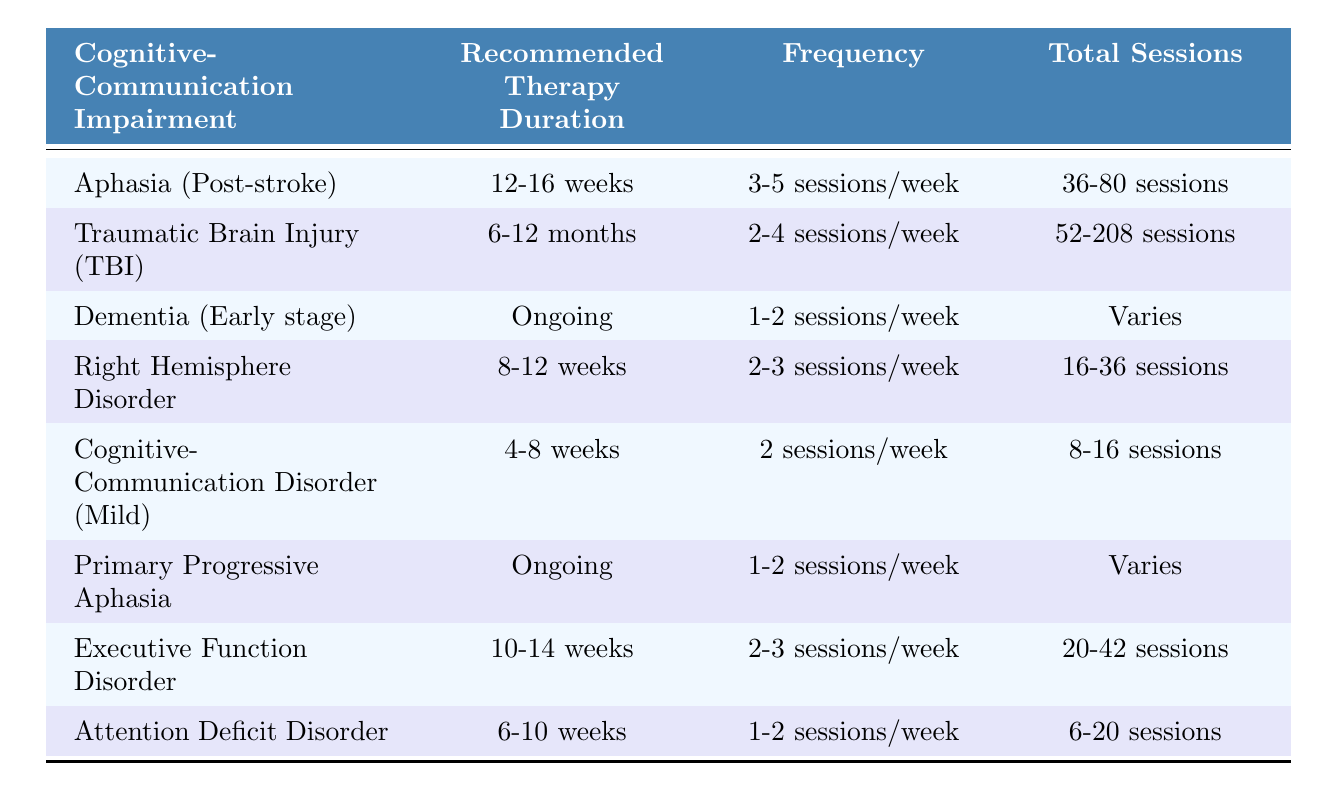What is the recommended therapy duration for Aphasia (Post-stroke)? According to the table, the recommended therapy duration for Aphasia (Post-stroke) is 12-16 weeks.
Answer: 12-16 weeks How many total sessions are recommended for Traumatic Brain Injury (TBI)? The table indicates that the total sessions recommended for Traumatic Brain Injury (TBI) range from 52 to 208 sessions.
Answer: 52-208 sessions Is the recommended therapy duration for Cognitive-Communication Disorder (Mild) longer than for Attention Deficit Disorder? One needs to compare the recommended durations, which are 4-8 weeks for Cognitive-Communication Disorder (Mild) and 6-10 weeks for Attention Deficit Disorder. Since 8 weeks (maximum of Mild) is less than 10 weeks (maximum of ADD), the answer is no.
Answer: No What is the total number of sessions for Executive Function Disorder? For Executive Function Disorder, the table shows the total sessions range from 20 to 42.
Answer: 20-42 sessions Which cognitive-communication impairment has an ongoing recommended therapy duration? The table lists two cognitive-communication impairments with an ongoing recommended therapy duration: Dementia (Early stage) and Primary Progressive Aphasia.
Answer: Dementia (Early stage) and Primary Progressive Aphasia What is the average total session range for the impairments with a specific duration? First, we identify the total session ranges for those impairments with defined durations: Aphasia (36-80), TBI (52-208), Right Hemisphere Disorder (16-36), Cognitive-Communication Disorder (8-16), Executive Function Disorder (20-42), Attention Deficit Disorder (6-20). First, we find the mean ranges: (36+80)/2=58, (52+208)/2=130, (16+36)/2=26, (8+16)/2=12, (20+42)/2=31, (6+20)/2=13. The average total of these averages is (58 + 130 + 26 + 12 + 31 + 13) / 6 = 44.
Answer: 44 Is the frequency for working with clients who have Right Hemisphere Disorder higher than that for those with Attention Deficit Disorder? Yes, the frequency for Right Hemisphere Disorder is 2-3 sessions/week, while for Attention Deficit Disorder it is 1-2 sessions/week. Given 3 is higher than 2, the frequency for Right Hemisphere Disorder is higher.
Answer: Yes How many total sessions are recommended for patients with Dementia in the early stages of their condition? The table shows that the total sessions for Dementia (Early stage) is categorized as "Varies", meaning it does not have a specific number indicated.
Answer: Varies 